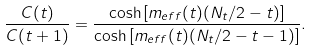<formula> <loc_0><loc_0><loc_500><loc_500>\frac { C ( t ) } { C ( t + 1 ) } = \frac { \cosh \left [ m _ { e f f } ( t ) ( N _ { t } / 2 - t ) \right ] } { \cosh \left [ m _ { e f f } ( t ) ( N _ { t } / 2 - t - 1 ) \right ] } .</formula> 